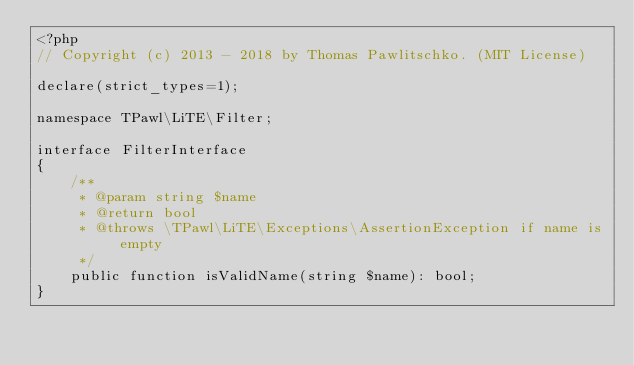Convert code to text. <code><loc_0><loc_0><loc_500><loc_500><_PHP_><?php
// Copyright (c) 2013 - 2018 by Thomas Pawlitschko. (MIT License)

declare(strict_types=1);

namespace TPawl\LiTE\Filter;

interface FilterInterface
{
    /**
     * @param string $name
     * @return bool
     * @throws \TPawl\LiTE\Exceptions\AssertionException if name is empty
     */
    public function isValidName(string $name): bool;
}
</code> 